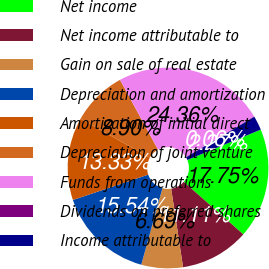Convert chart to OTSL. <chart><loc_0><loc_0><loc_500><loc_500><pie_chart><fcel>Net income<fcel>Net income attributable to<fcel>Gain on sale of real estate<fcel>Depreciation and amortization<fcel>Amortization of initial direct<fcel>Depreciation of joint venture<fcel>Funds from operations<fcel>Dividends on preferred shares<fcel>Income attributable to<nl><fcel>17.75%<fcel>11.11%<fcel>6.69%<fcel>15.54%<fcel>13.33%<fcel>8.9%<fcel>24.36%<fcel>0.06%<fcel>2.27%<nl></chart> 